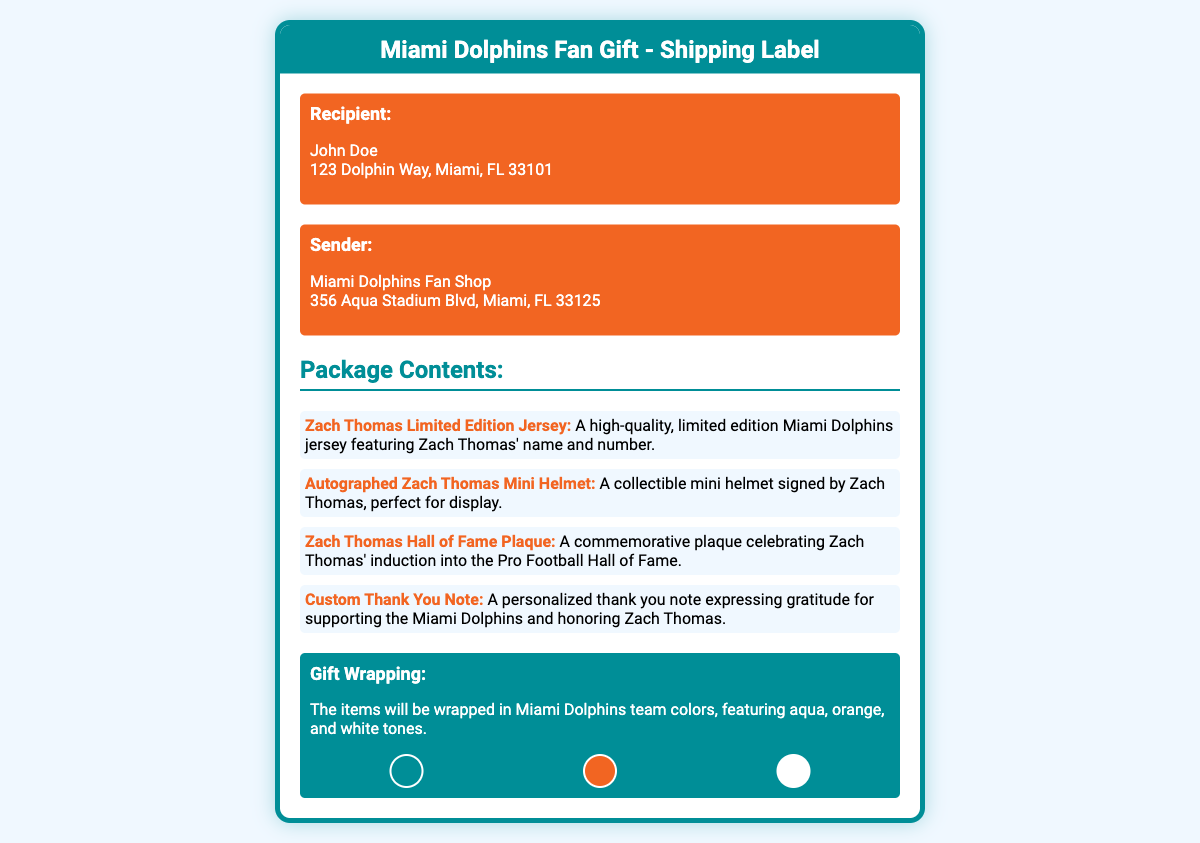What is the recipient's name? The recipient's name is specified directly in the address section of the document.
Answer: John Doe What is the shipping address? The shipping address is detailed in the address section of the document.
Answer: 123 Dolphin Way, Miami, FL 33101 What item features Zach Thomas' name and number? The document lists items included in the package, specifically mentioning one with Zach Thomas' name and number.
Answer: Zach Thomas Limited Edition Jersey How many items are included in the package? The number of items can be counted in the package contents section of the document.
Answer: Four What is featured on the autographed mini helmet? The description of the mini helmet provides details on what it contains.
Answer: Signed by Zach Thomas What colors are used for the gift wrapping? The document describes the colors that will be used for the gift wrapping.
Answer: Aqua, orange, and white What type of note is included in the package? The package contents specifically state the kind of note included.
Answer: Custom Thank You Note What significant achievement of Zach Thomas is celebrated in the plaque? The description of the plaque states what achievement it commemorates.
Answer: Hall of Fame induction What is the sender's name? The sender's name is clearly mentioned in the sender's address section of the document.
Answer: Miami Dolphins Fan Shop 